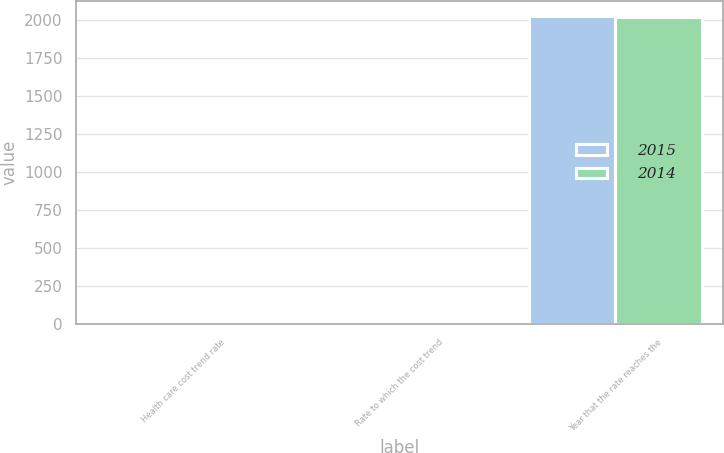Convert chart to OTSL. <chart><loc_0><loc_0><loc_500><loc_500><stacked_bar_chart><ecel><fcel>Health care cost trend rate<fcel>Rate to which the cost trend<fcel>Year that the rate reaches the<nl><fcel>2015<fcel>7.29<fcel>5<fcel>2026<nl><fcel>2014<fcel>7.36<fcel>5<fcel>2020<nl></chart> 